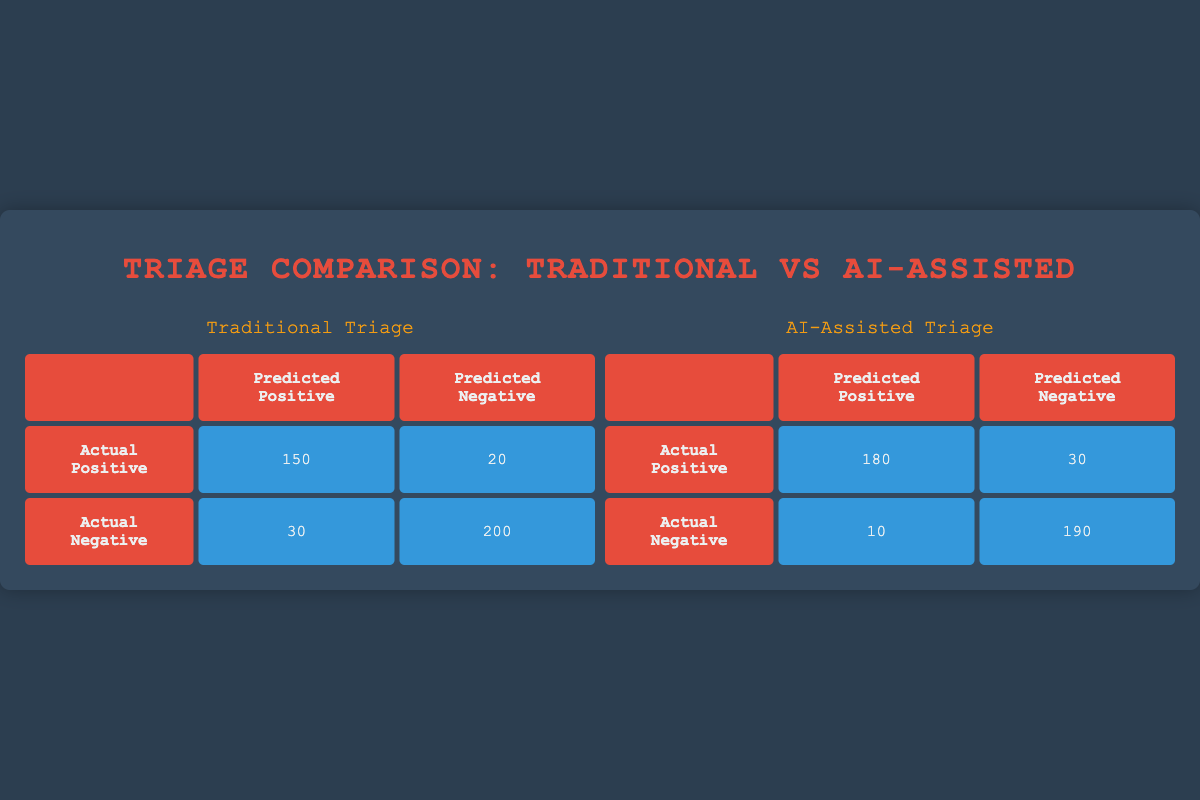What is the number of correct positives in traditional triage? The table for traditional triage shows that the number of correct positives is in the cell under "Actual Positive" and "Predicted Positive," which is 150.
Answer: 150 How many incorrect negatives are there in AI-assisted triage? In the AI-assisted triage table, the cell that corresponds to "Actual Positive" and "Predicted Negative" shows the number of incorrect negatives, which is 30.
Answer: 30 What is the total number of actual positives in traditional triage? To find the total number of actual positives in traditional triage, add the correct positives and incorrect negatives: 150 (correct positives) + 20 (incorrect negatives) = 170.
Answer: 170 What is the difference in incorrect positives between traditional and AI-assisted triage? The traditional triage has 30 incorrect positives and the AI-assisted triage has 10 incorrect positives. The difference is 30 - 10 = 20.
Answer: 20 Is the number of correct negatives higher in AI-assisted triage compared to traditional triage? In traditional triage, the number of correct negatives is 200, while in AI-assisted triage, it is 190. Since 200 is greater than 190, the statement is false.
Answer: No What is the total number of predictions made by the AI-assisted triage? To calculate total predictions in AI-assisted triage, sum all values within the matrix: 180 (correct positives) + 10 (incorrect positives) + 30 (incorrect negatives) + 190 (correct negatives) = 410.
Answer: 410 What percentage of actual positives were correctly identified by traditional triage methods? The correct positives are 150 out of a total of 170 actual positives (150 correct positives + 20 incorrect negatives). To find the percentage, (150/170) * 100 = 88.24%.
Answer: 88.24% Which method has a higher accuracy for predicting negatives? To find the accuracy for predicting negatives, we calculate for both methods: Traditional triage accuracy = 200 correct negatives out of 230 total predicted negatives (200 correct negatives + 30 incorrect positives), which is about 86.96%. AI-assisted triage accuracy = 190 correct negatives out of 200 total predicted negatives (190 correct negatives + 10 incorrect positives), which is 95%. As 95% is higher than 86.96%, AI-assisted triage has higher accuracy.
Answer: AI-assisted triage How many total incorrect predictions were made by traditional triage? To find total incorrect predictions in traditional triage, sum the incorrect positives and incorrect negatives: 30 (incorrect positives) + 20 (incorrect negatives) = 50.
Answer: 50 